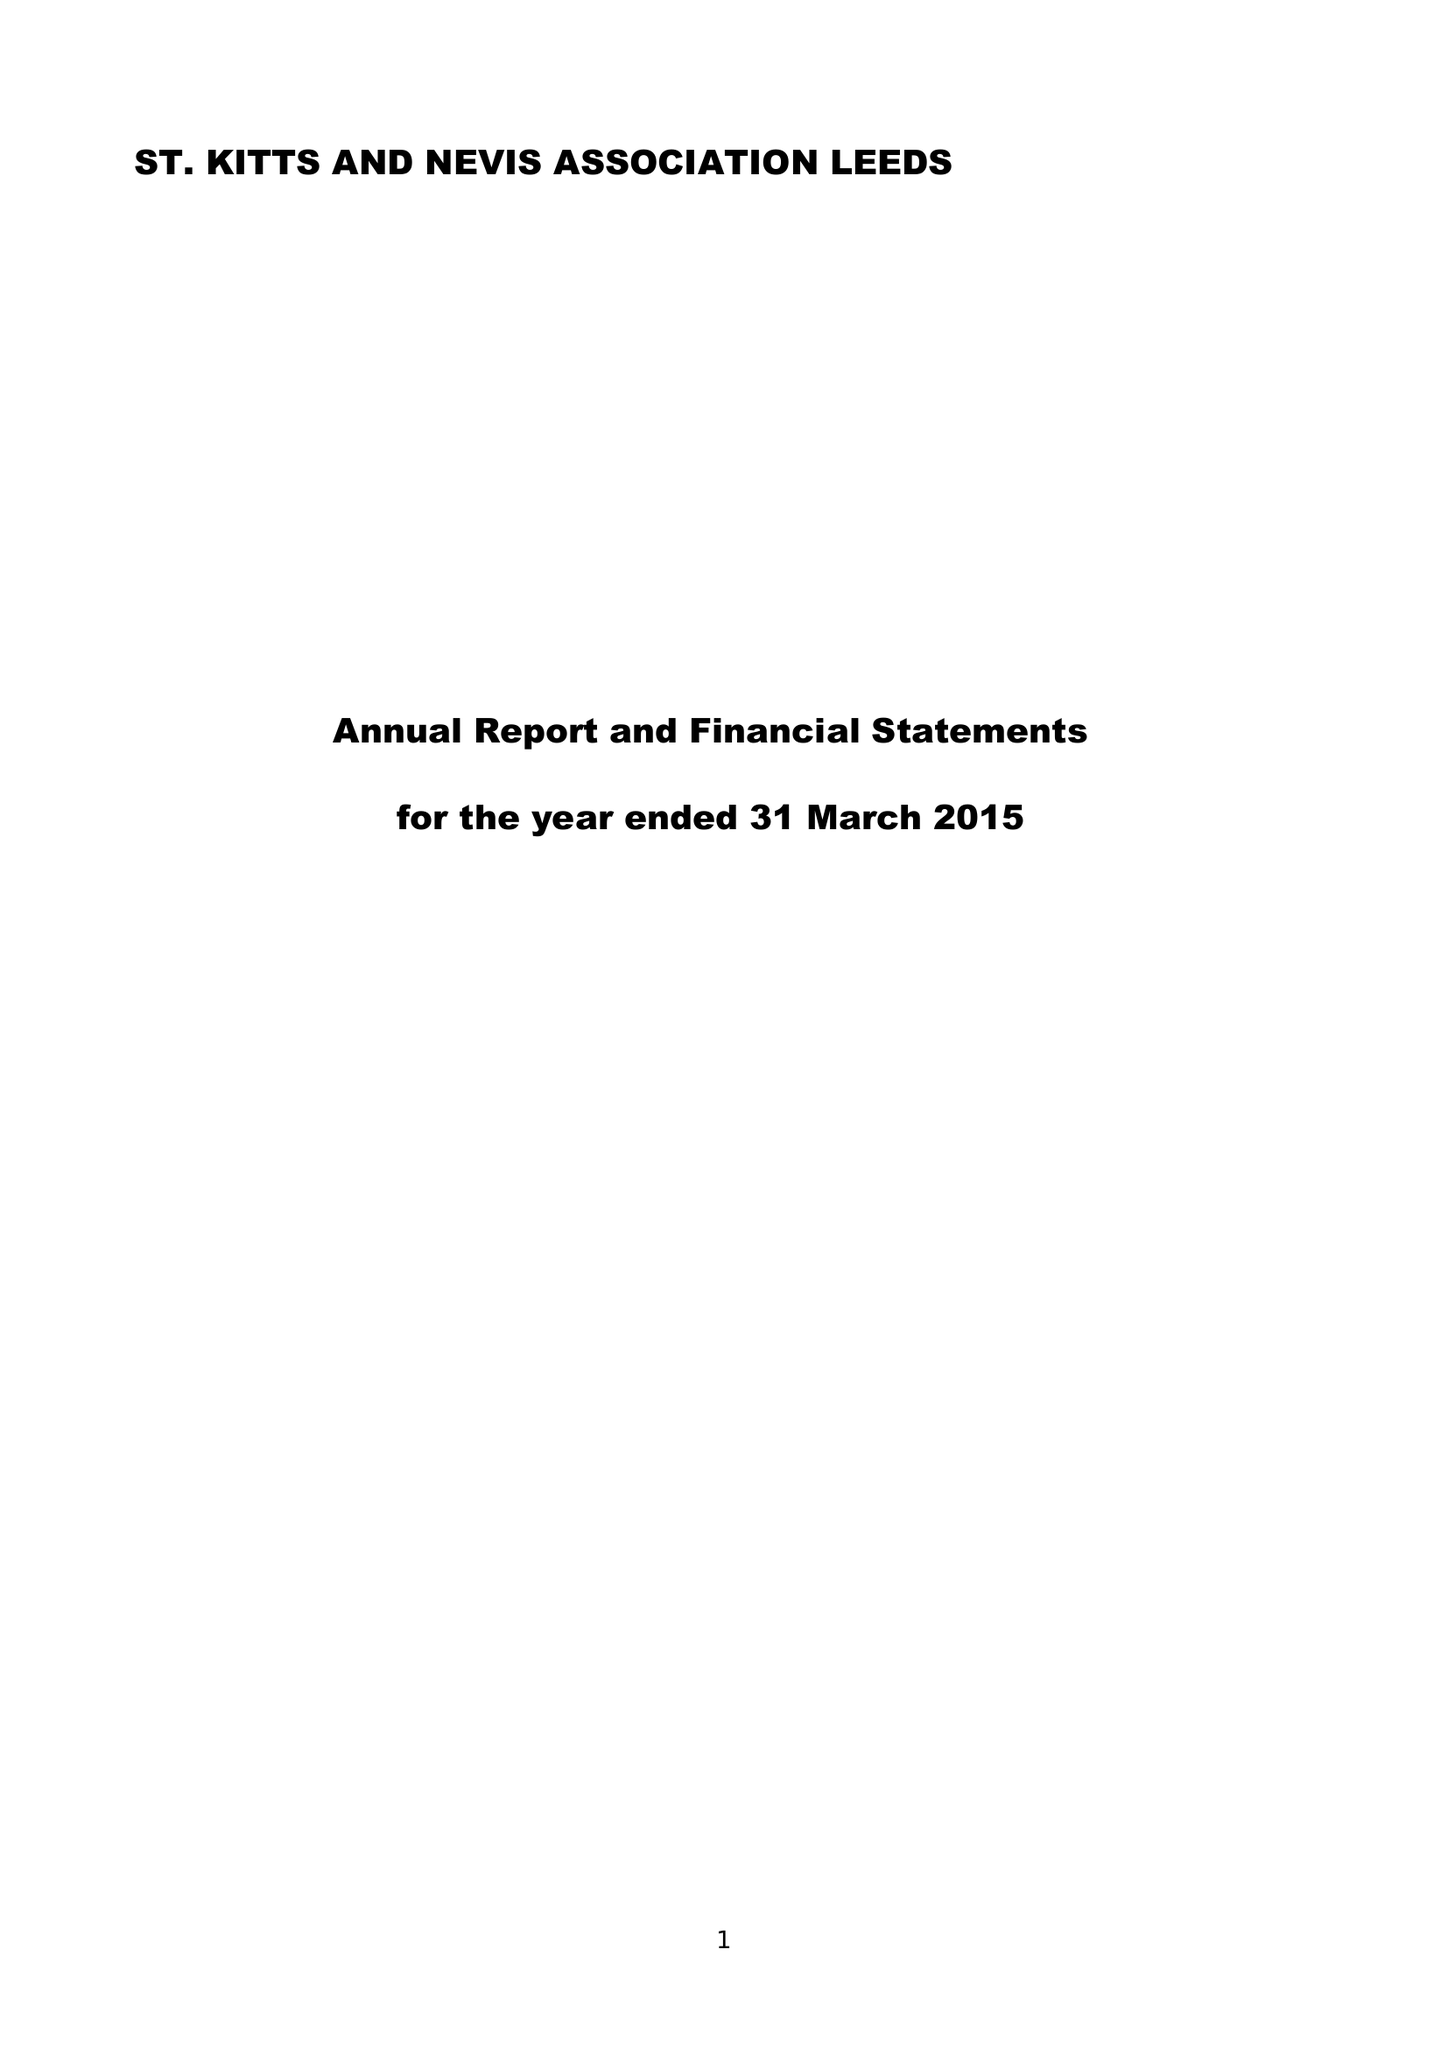What is the value for the report_date?
Answer the question using a single word or phrase. 2015-03-31 